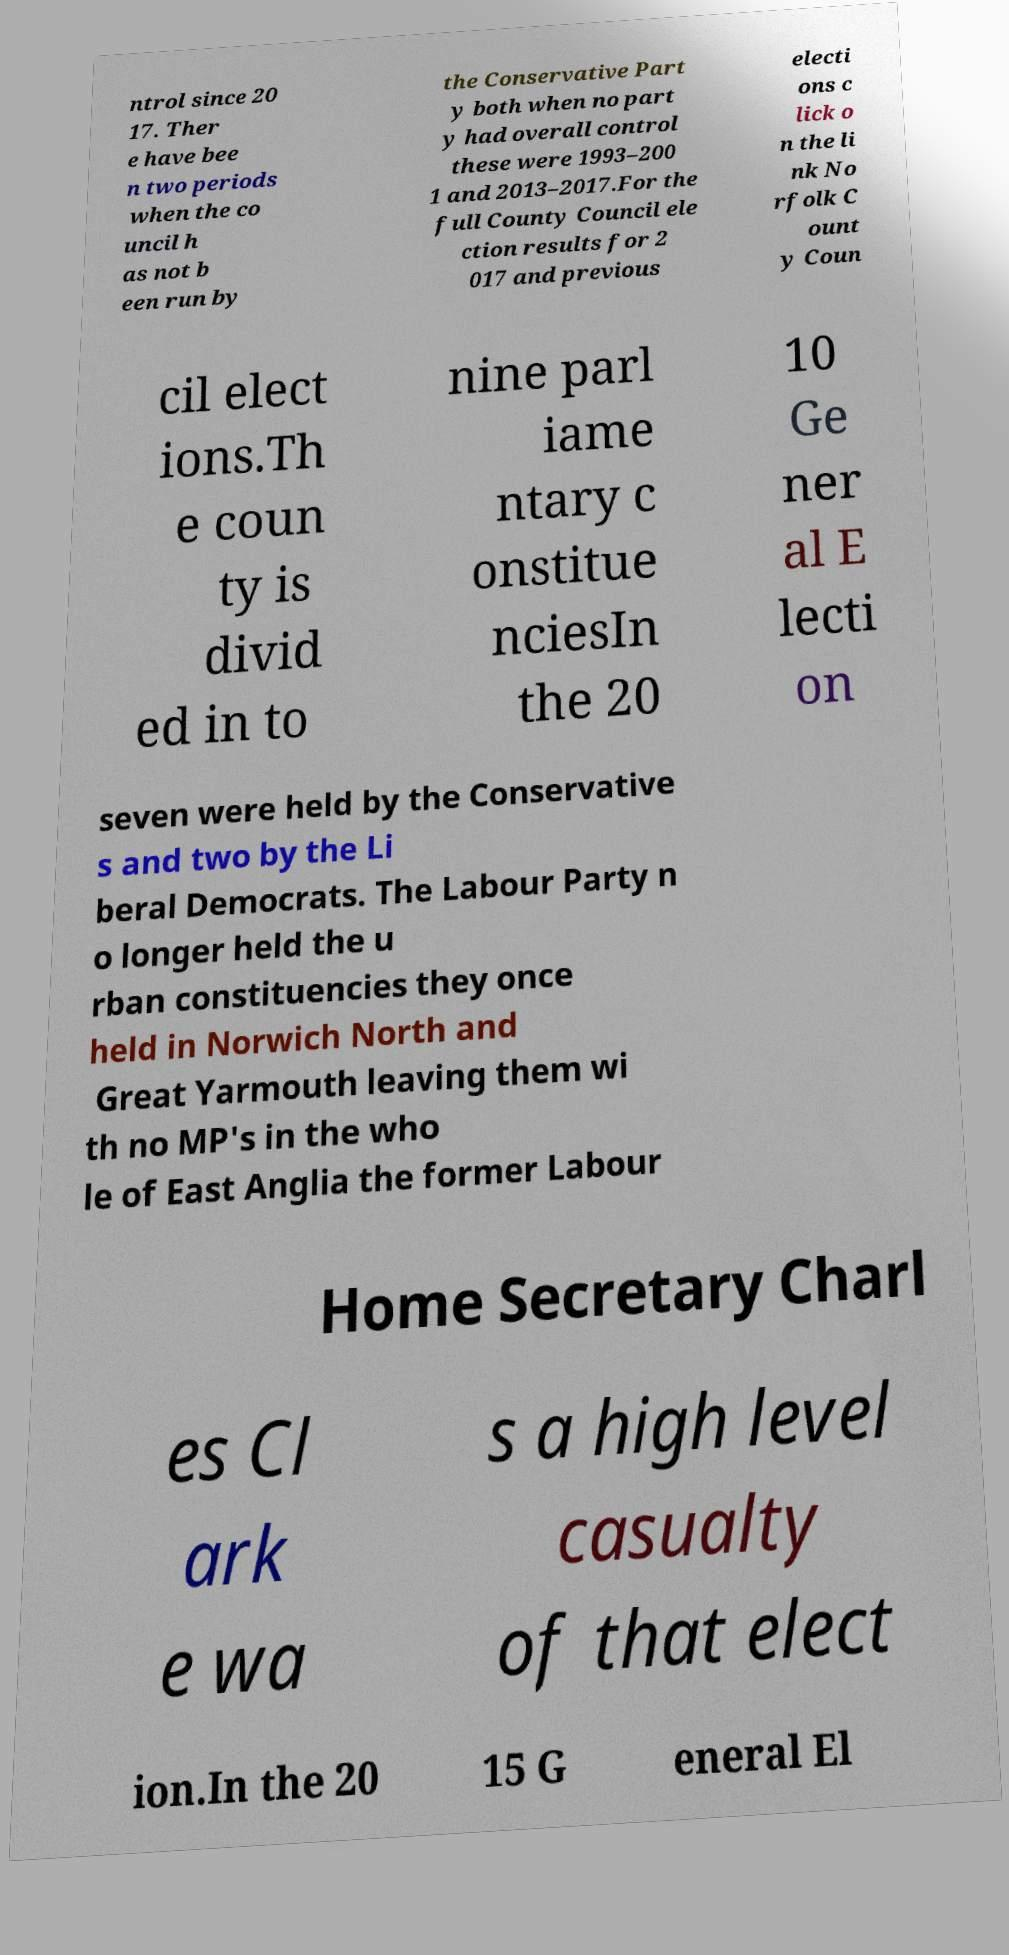I need the written content from this picture converted into text. Can you do that? ntrol since 20 17. Ther e have bee n two periods when the co uncil h as not b een run by the Conservative Part y both when no part y had overall control these were 1993–200 1 and 2013–2017.For the full County Council ele ction results for 2 017 and previous electi ons c lick o n the li nk No rfolk C ount y Coun cil elect ions.Th e coun ty is divid ed in to nine parl iame ntary c onstitue nciesIn the 20 10 Ge ner al E lecti on seven were held by the Conservative s and two by the Li beral Democrats. The Labour Party n o longer held the u rban constituencies they once held in Norwich North and Great Yarmouth leaving them wi th no MP's in the who le of East Anglia the former Labour Home Secretary Charl es Cl ark e wa s a high level casualty of that elect ion.In the 20 15 G eneral El 